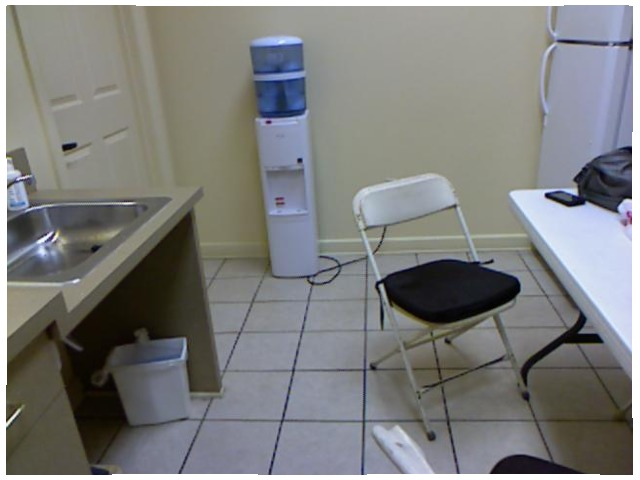<image>
Can you confirm if the trash can is under the sink? Yes. The trash can is positioned underneath the sink, with the sink above it in the vertical space. Is the waste basket to the left of the chair? Yes. From this viewpoint, the waste basket is positioned to the left side relative to the chair. Where is the table in relation to the chair? Is it to the left of the chair? No. The table is not to the left of the chair. From this viewpoint, they have a different horizontal relationship. Is there a bag in the can? Yes. The bag is contained within or inside the can, showing a containment relationship. 